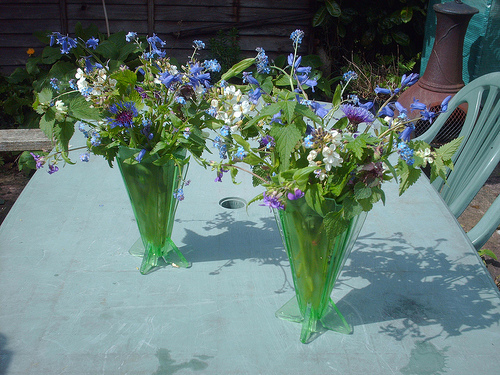Please provide a short description for this region: [0.81, 0.26, 1.0, 0.62]. Positioned on the right, a green handwoven lawn chair sits partly shaded under a lush canopy, offering a tranquil spot for relaxation. 